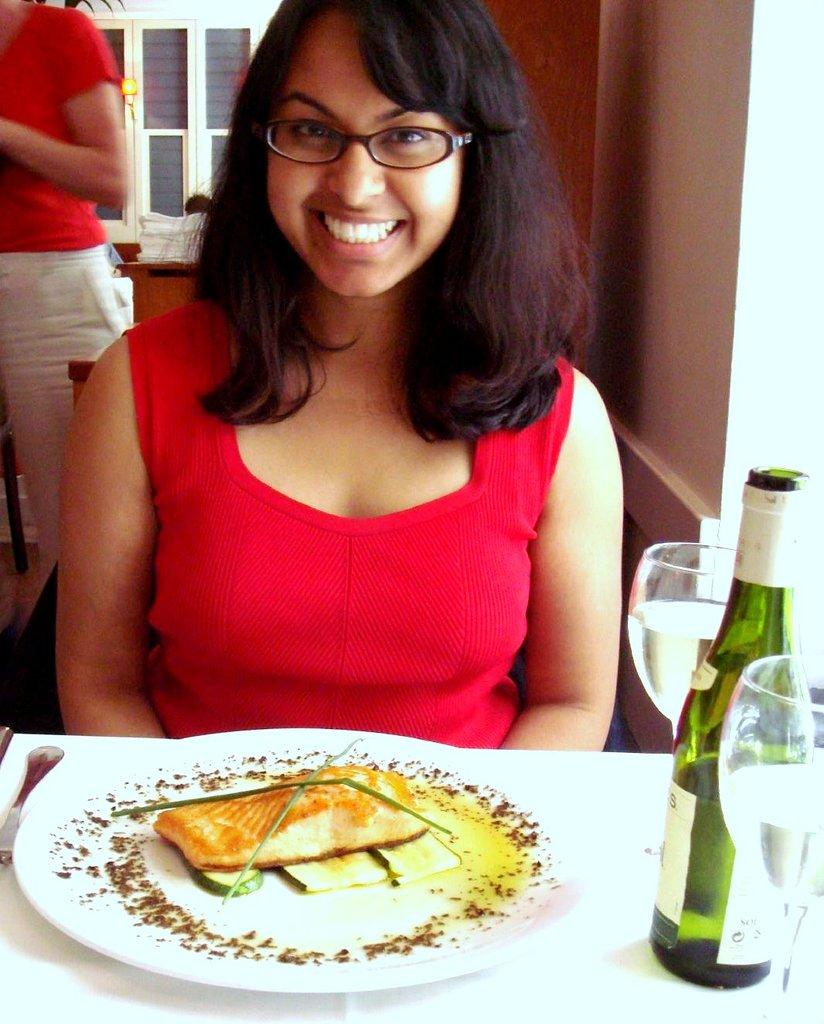Who is present in the image? There is a woman in the image. What is the woman doing in the image? The woman is smiling. What can be seen on the table in the image? There is food on a plate, two glasses, and a bottle on the table. Can you describe the other person in the image? There is another person in the background of the image. What type of hair is the woman using to drink from the straw in the image? There is no straw or hair present in the image. What punishment is the woman receiving for her actions in the image? There is no indication of any punishment in the image; the woman is simply smiling. 